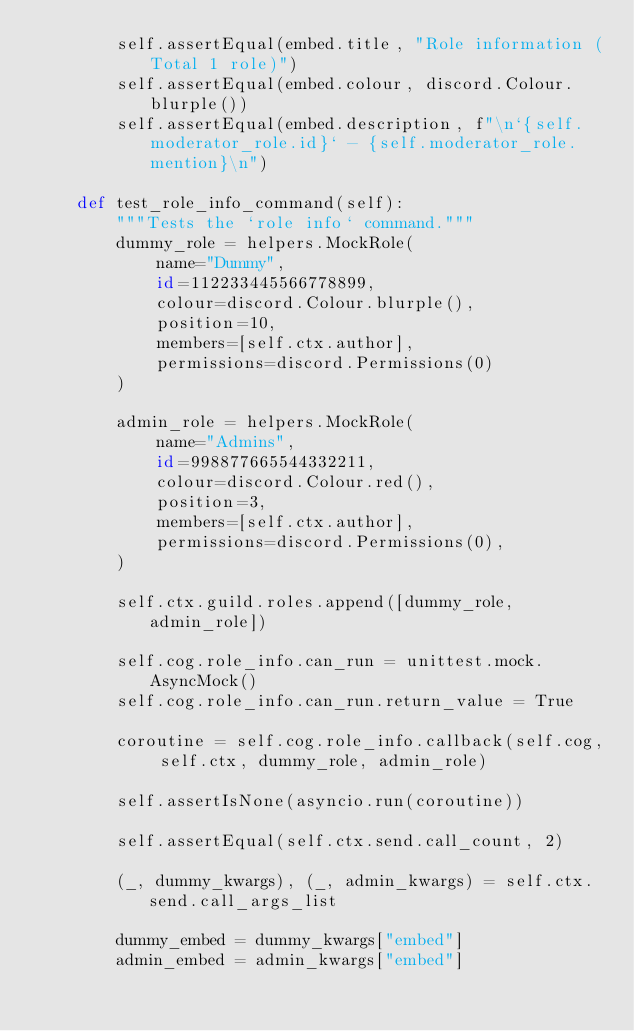<code> <loc_0><loc_0><loc_500><loc_500><_Python_>        self.assertEqual(embed.title, "Role information (Total 1 role)")
        self.assertEqual(embed.colour, discord.Colour.blurple())
        self.assertEqual(embed.description, f"\n`{self.moderator_role.id}` - {self.moderator_role.mention}\n")

    def test_role_info_command(self):
        """Tests the `role info` command."""
        dummy_role = helpers.MockRole(
            name="Dummy",
            id=112233445566778899,
            colour=discord.Colour.blurple(),
            position=10,
            members=[self.ctx.author],
            permissions=discord.Permissions(0)
        )

        admin_role = helpers.MockRole(
            name="Admins",
            id=998877665544332211,
            colour=discord.Colour.red(),
            position=3,
            members=[self.ctx.author],
            permissions=discord.Permissions(0),
        )

        self.ctx.guild.roles.append([dummy_role, admin_role])

        self.cog.role_info.can_run = unittest.mock.AsyncMock()
        self.cog.role_info.can_run.return_value = True

        coroutine = self.cog.role_info.callback(self.cog, self.ctx, dummy_role, admin_role)

        self.assertIsNone(asyncio.run(coroutine))

        self.assertEqual(self.ctx.send.call_count, 2)

        (_, dummy_kwargs), (_, admin_kwargs) = self.ctx.send.call_args_list

        dummy_embed = dummy_kwargs["embed"]
        admin_embed = admin_kwargs["embed"]
</code> 